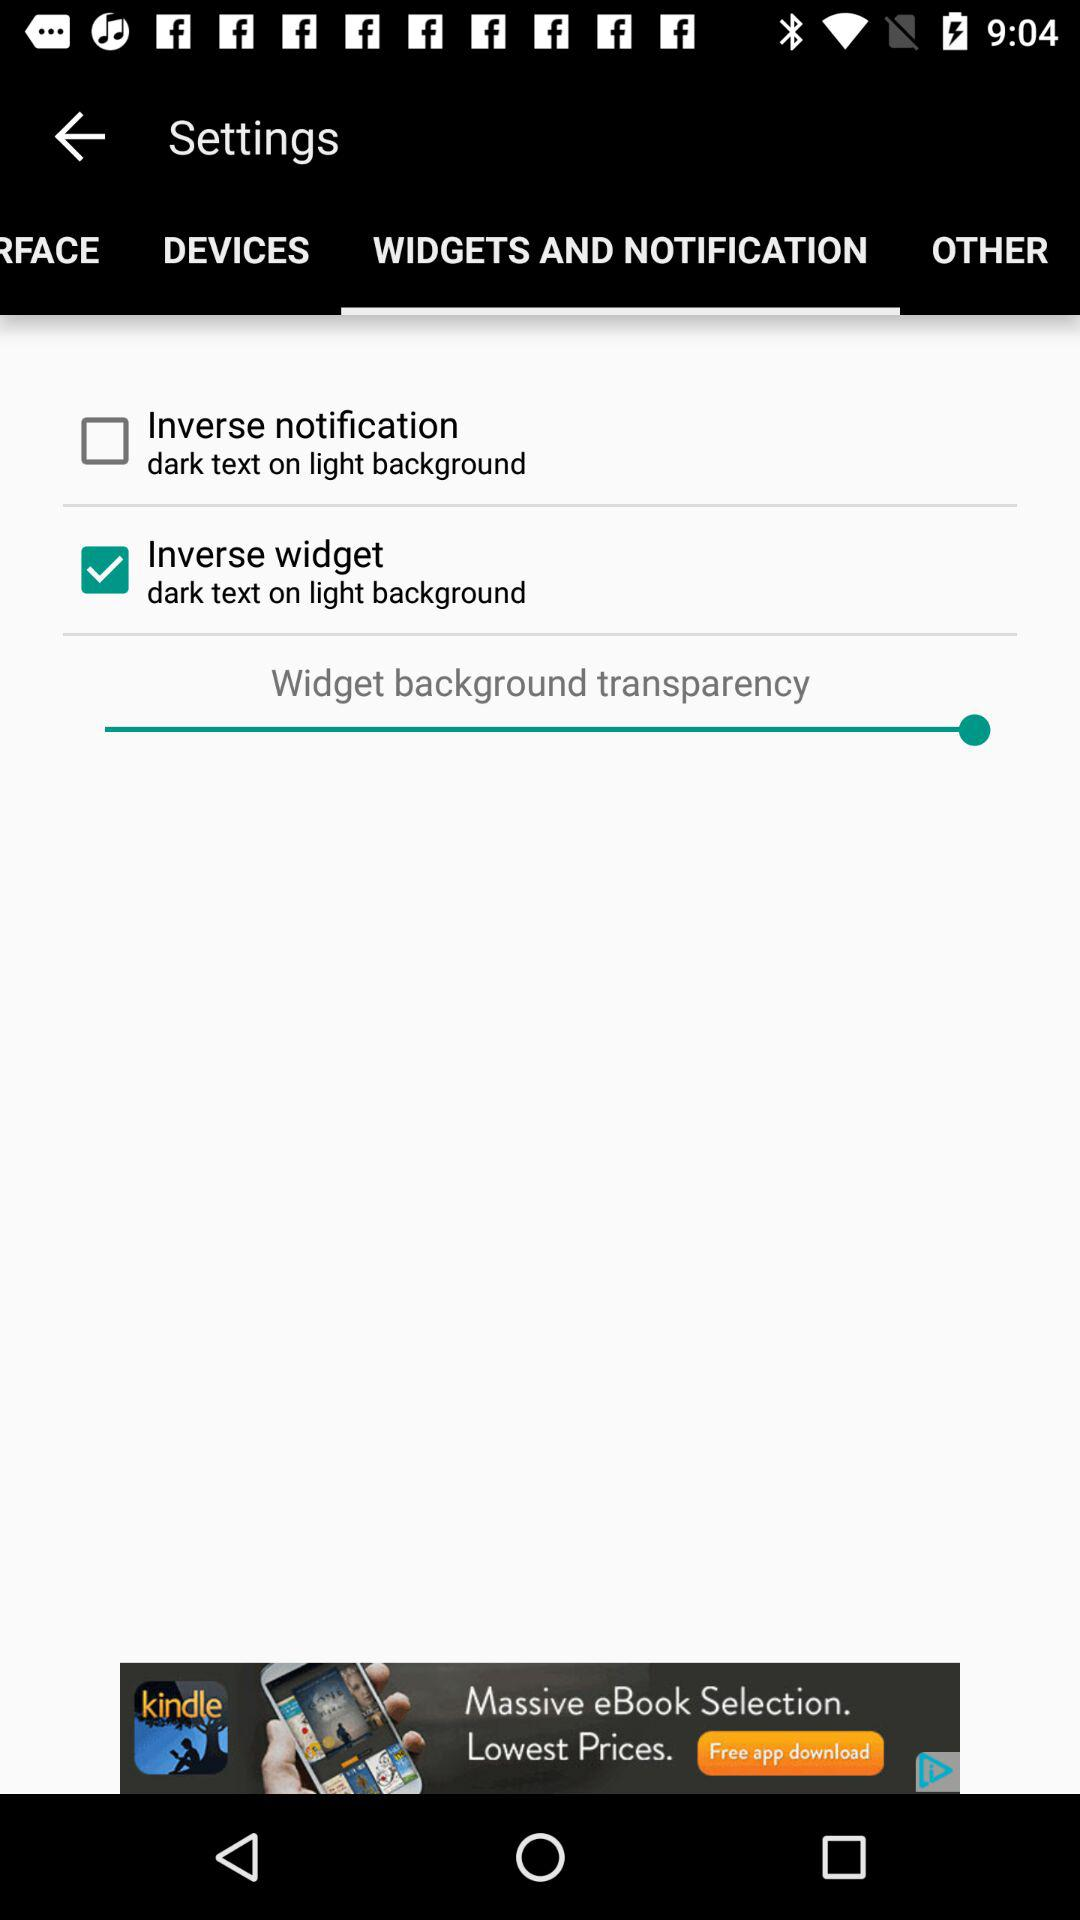What is the status of the "Inverse widget"? The status is "on". 